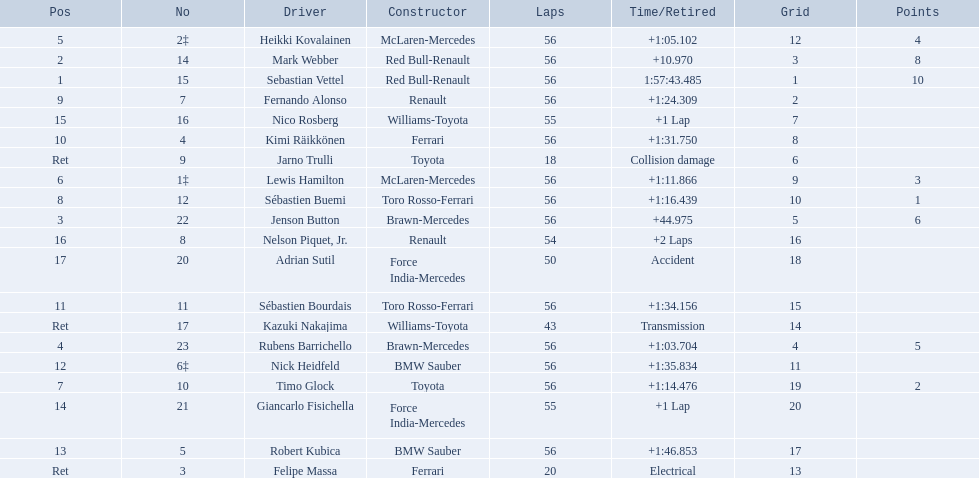Who are all the drivers? Sebastian Vettel, Mark Webber, Jenson Button, Rubens Barrichello, Heikki Kovalainen, Lewis Hamilton, Timo Glock, Sébastien Buemi, Fernando Alonso, Kimi Räikkönen, Sébastien Bourdais, Nick Heidfeld, Robert Kubica, Giancarlo Fisichella, Nico Rosberg, Nelson Piquet, Jr., Adrian Sutil, Kazuki Nakajima, Felipe Massa, Jarno Trulli. What were their finishing times? 1:57:43.485, +10.970, +44.975, +1:03.704, +1:05.102, +1:11.866, +1:14.476, +1:16.439, +1:24.309, +1:31.750, +1:34.156, +1:35.834, +1:46.853, +1 Lap, +1 Lap, +2 Laps, Accident, Transmission, Electrical, Collision damage. Who finished last? Robert Kubica. 